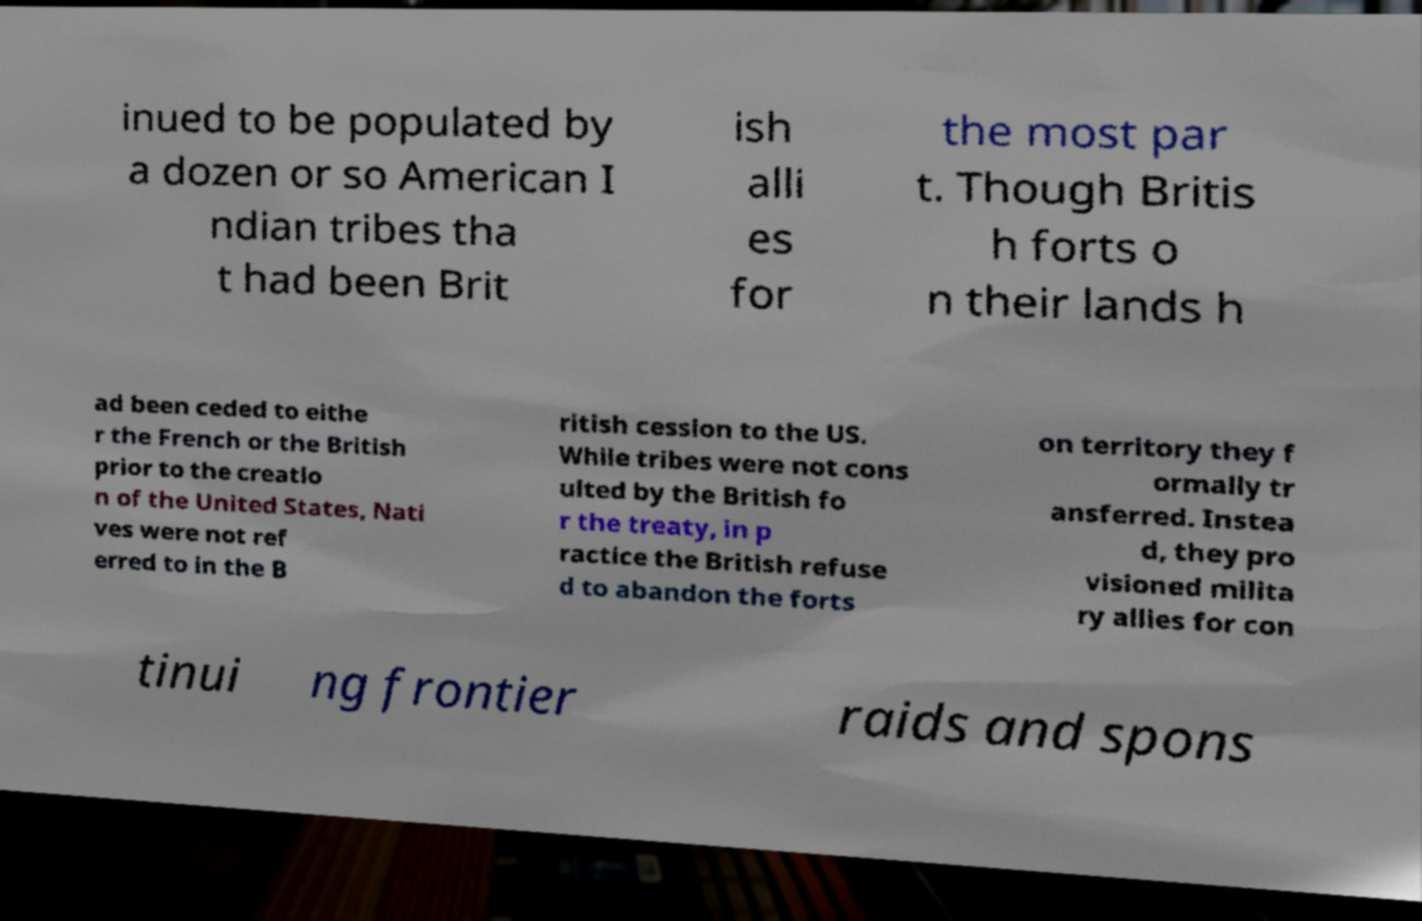Can you read and provide the text displayed in the image?This photo seems to have some interesting text. Can you extract and type it out for me? inued to be populated by a dozen or so American I ndian tribes tha t had been Brit ish alli es for the most par t. Though Britis h forts o n their lands h ad been ceded to eithe r the French or the British prior to the creatio n of the United States, Nati ves were not ref erred to in the B ritish cession to the US. While tribes were not cons ulted by the British fo r the treaty, in p ractice the British refuse d to abandon the forts on territory they f ormally tr ansferred. Instea d, they pro visioned milita ry allies for con tinui ng frontier raids and spons 